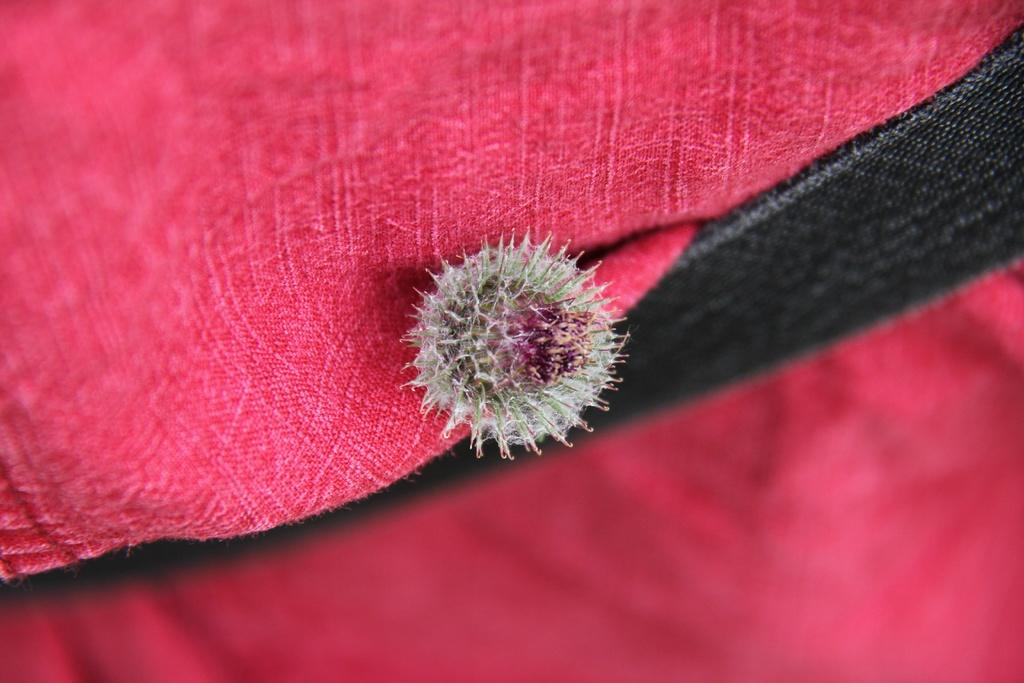What is the main subject of the image? The main subject of the image is a seed. What colors are present in the background of the image? The background of the image includes red and black colors. Can you tell me how many dogs are visible in the image? There are no dogs present in the image; it features a seed and a background with red and black colors. What type of leather is used to make the clouds in the image? There are no clouds or leather present in the image. 